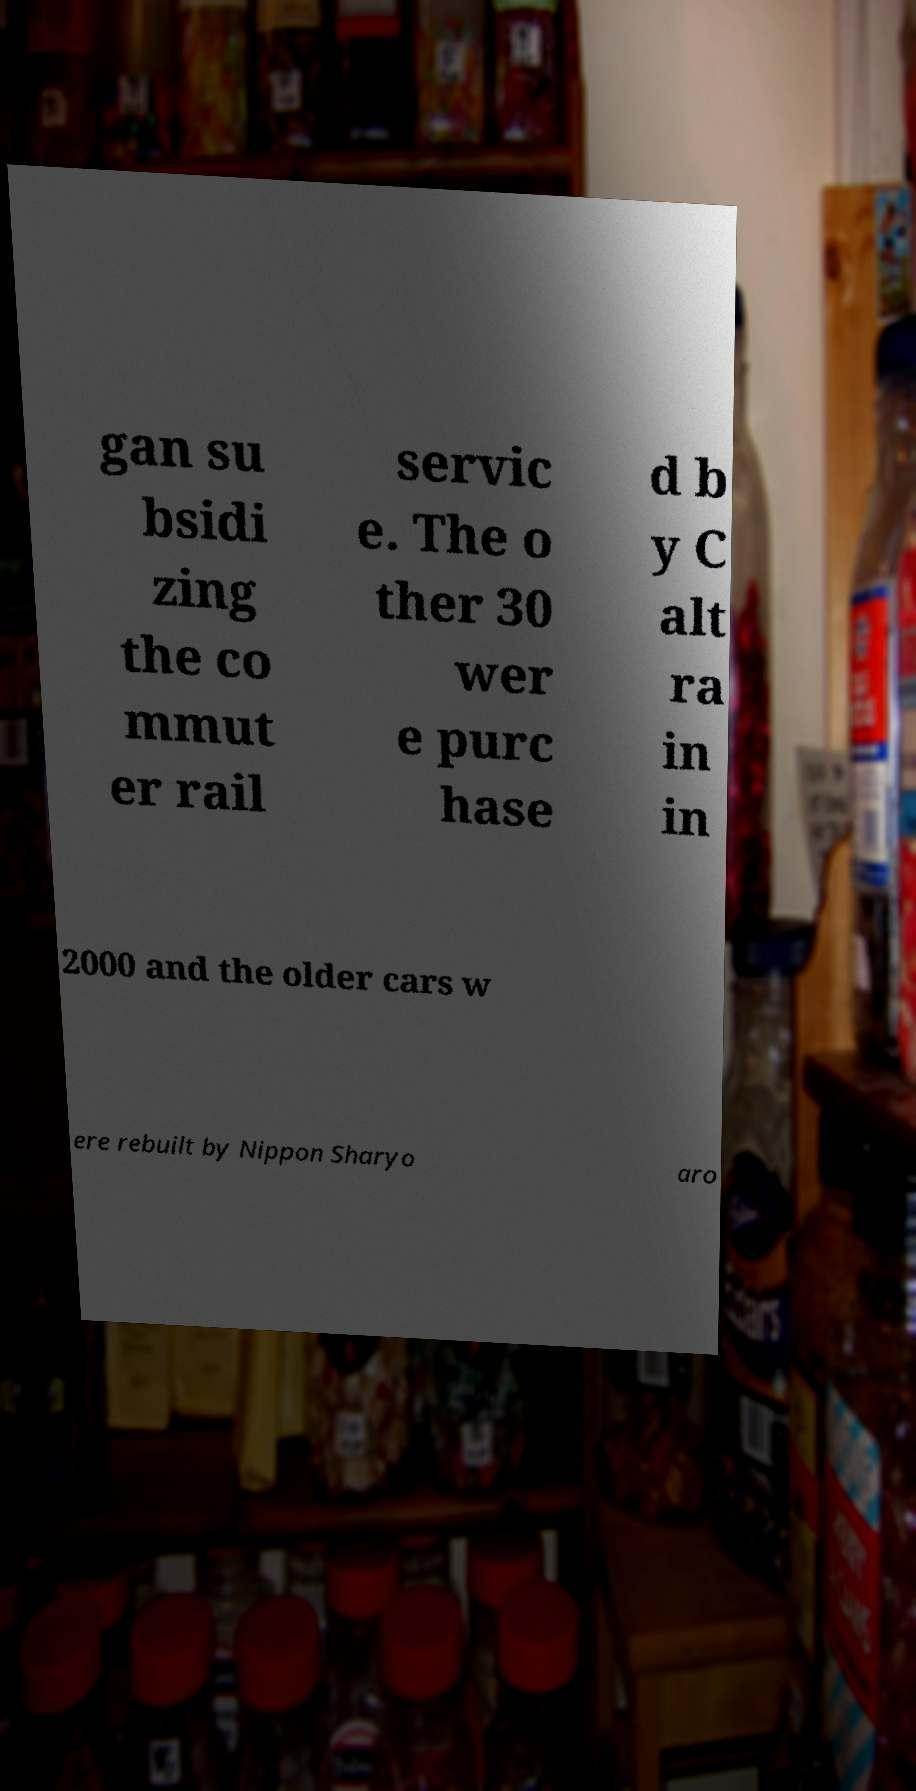Can you read and provide the text displayed in the image?This photo seems to have some interesting text. Can you extract and type it out for me? gan su bsidi zing the co mmut er rail servic e. The o ther 30 wer e purc hase d b y C alt ra in in 2000 and the older cars w ere rebuilt by Nippon Sharyo aro 